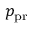<formula> <loc_0><loc_0><loc_500><loc_500>p _ { p r }</formula> 